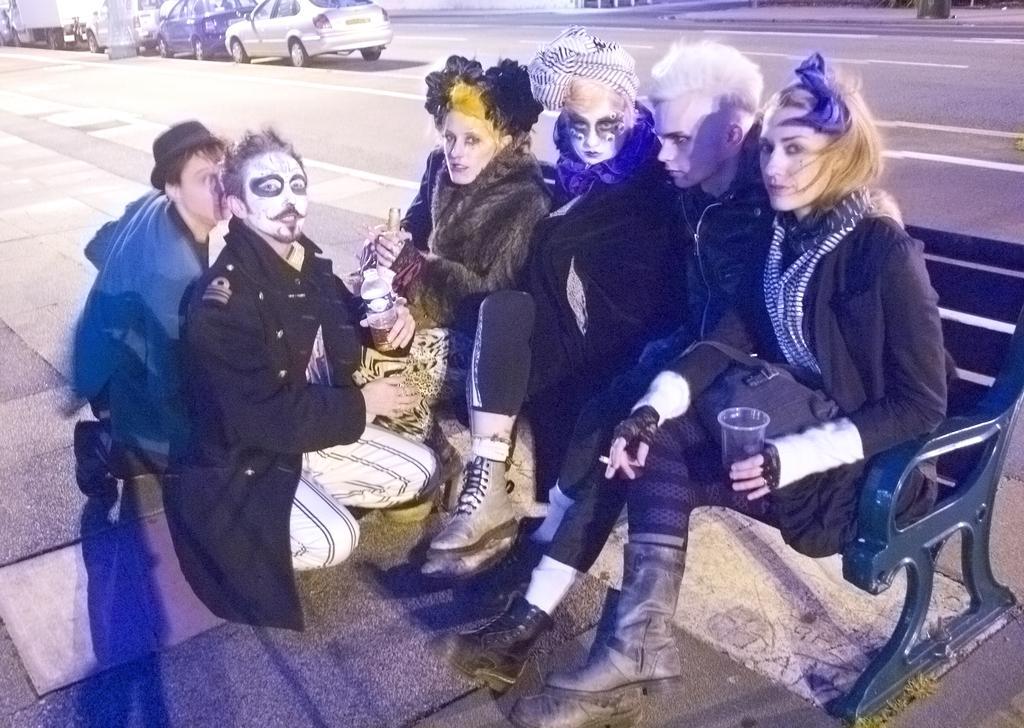Can you describe this image briefly? In the image there are a group of people the foreground, they are wearing some paints on their faces and behind them there is a road and on the left side there are vehicles. 